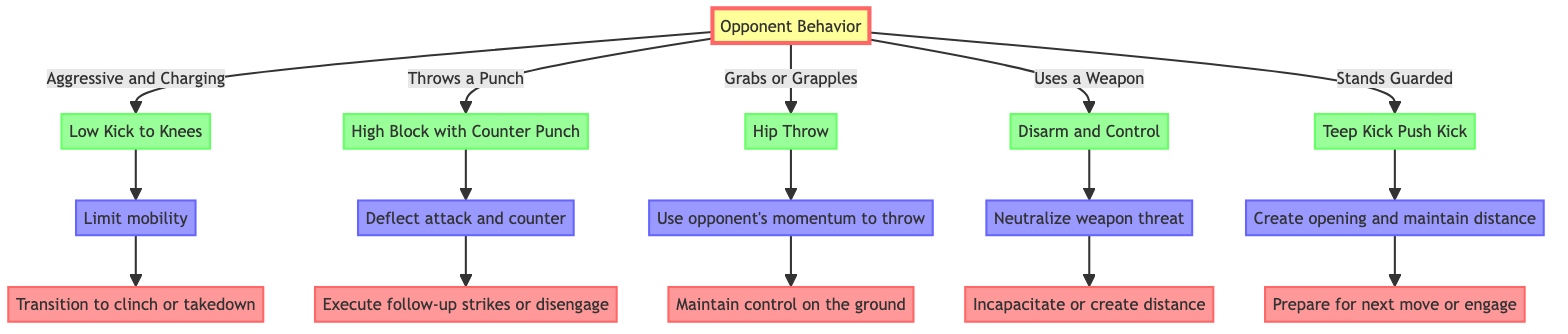What is the main factor for deciding the self-defense technique? The diagram's root node is "Opponent Behavior," indicating that this is the primary factor for determining which technique to use in self-defense scenarios.
Answer: Opponent Behavior What technique is used when the opponent grabs or grapples? According to the diagram, when the opponent is in a grabbing or grappling situation, the suggested technique is a "Hip Throw."
Answer: Hip Throw How many self-defense techniques are suggested in the diagram? The branches of the decision tree show five different conditions leading to the respective techniques, thus there are five techniques suggested.
Answer: 5 What is the follow-up action after using a Low Kick to Knees? The diagram specifies that the follow-up action after executing a Low Kick to Knees is to "Transition to clinch or takedown."
Answer: Transition to clinch or takedown If the opponent stands guarded, what is the purpose of the Teep Kick? The diagram states that the purpose of the Teep Kick, when used against a guarded opponent, is to "Create opening and maintain distance."
Answer: Create opening and maintain distance What is the technique for when the opponent uses a weapon? The decision tree indicates that if the opponent is wielding a weapon (like a knife or club), the recommended technique is "Disarm and Control."
Answer: Disarm and Control What does the diagram suggest to do if the opponent throws a punch? The diagram suggests performing a "High Block with Counter Punch" when the opponent throws a punch aimed at the head.
Answer: High Block with Counter Punch Which technique involves using the opponent's momentum? The "Hip Throw" technique is specifically designed to utilize the opponent's momentum to execute the throw effectively.
Answer: Hip Throw 